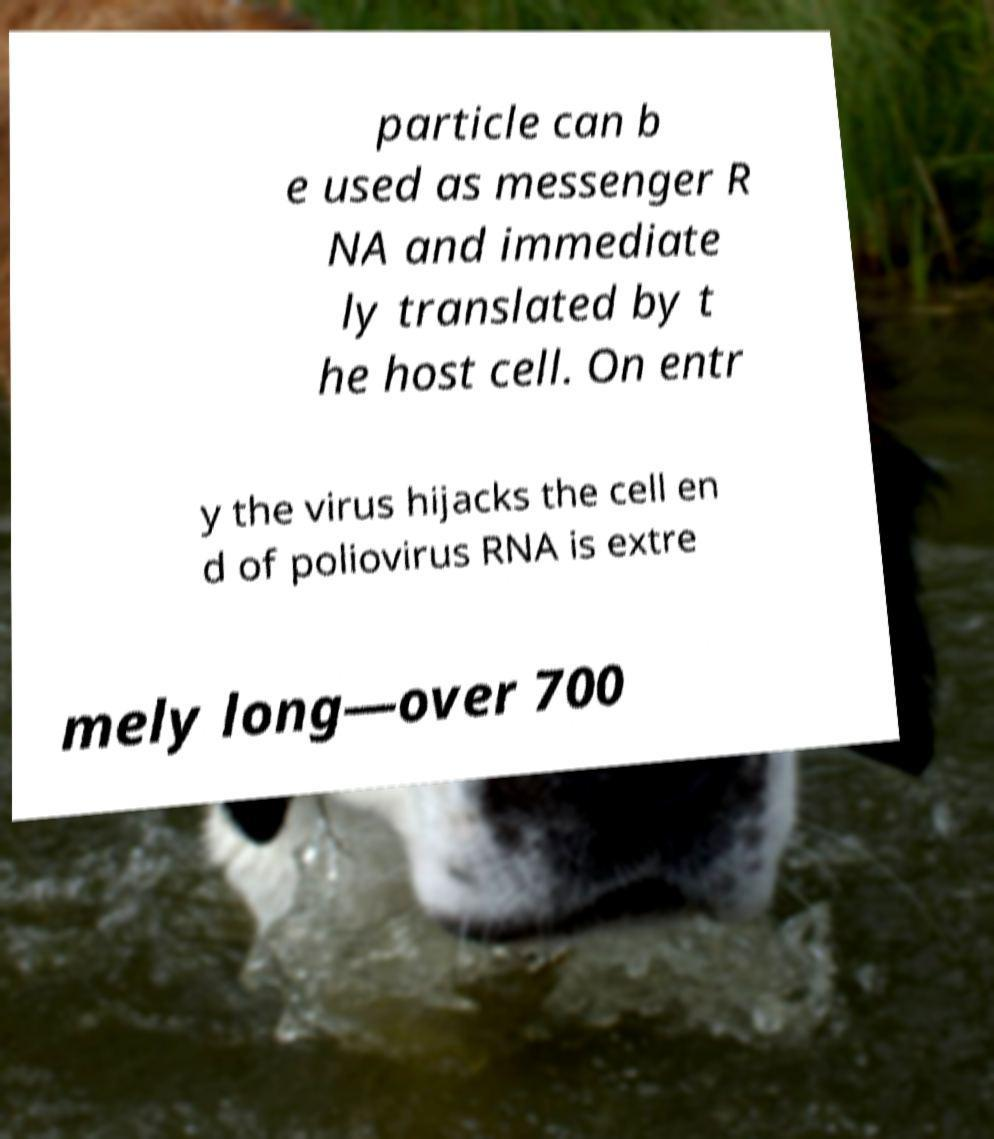There's text embedded in this image that I need extracted. Can you transcribe it verbatim? particle can b e used as messenger R NA and immediate ly translated by t he host cell. On entr y the virus hijacks the cell en d of poliovirus RNA is extre mely long—over 700 